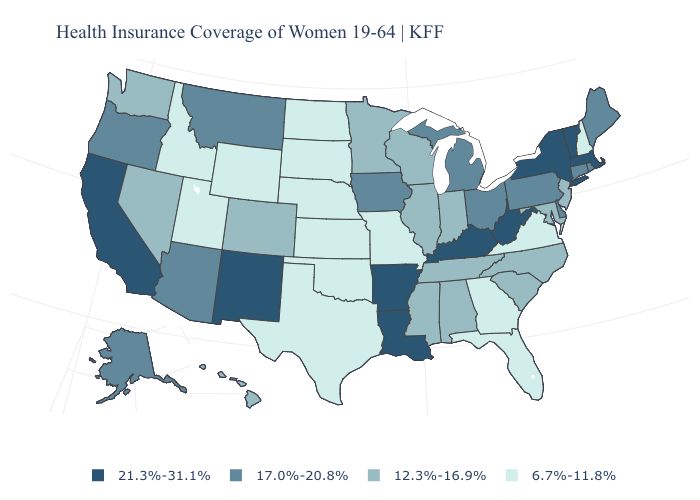Which states hav the highest value in the West?
Give a very brief answer. California, New Mexico. Name the states that have a value in the range 17.0%-20.8%?
Concise answer only. Alaska, Arizona, Connecticut, Delaware, Iowa, Maine, Michigan, Montana, Ohio, Oregon, Pennsylvania, Rhode Island. Does Montana have the lowest value in the West?
Be succinct. No. What is the value of Oregon?
Be succinct. 17.0%-20.8%. Name the states that have a value in the range 6.7%-11.8%?
Be succinct. Florida, Georgia, Idaho, Kansas, Missouri, Nebraska, New Hampshire, North Dakota, Oklahoma, South Dakota, Texas, Utah, Virginia, Wyoming. What is the lowest value in states that border Massachusetts?
Answer briefly. 6.7%-11.8%. Name the states that have a value in the range 6.7%-11.8%?
Keep it brief. Florida, Georgia, Idaho, Kansas, Missouri, Nebraska, New Hampshire, North Dakota, Oklahoma, South Dakota, Texas, Utah, Virginia, Wyoming. What is the value of North Dakota?
Be succinct. 6.7%-11.8%. Does the map have missing data?
Concise answer only. No. What is the value of Colorado?
Give a very brief answer. 12.3%-16.9%. What is the value of Pennsylvania?
Answer briefly. 17.0%-20.8%. Does North Carolina have the same value as Rhode Island?
Write a very short answer. No. Does New Hampshire have the lowest value in the Northeast?
Quick response, please. Yes. What is the value of Montana?
Quick response, please. 17.0%-20.8%. Which states have the highest value in the USA?
Quick response, please. Arkansas, California, Kentucky, Louisiana, Massachusetts, New Mexico, New York, Vermont, West Virginia. 